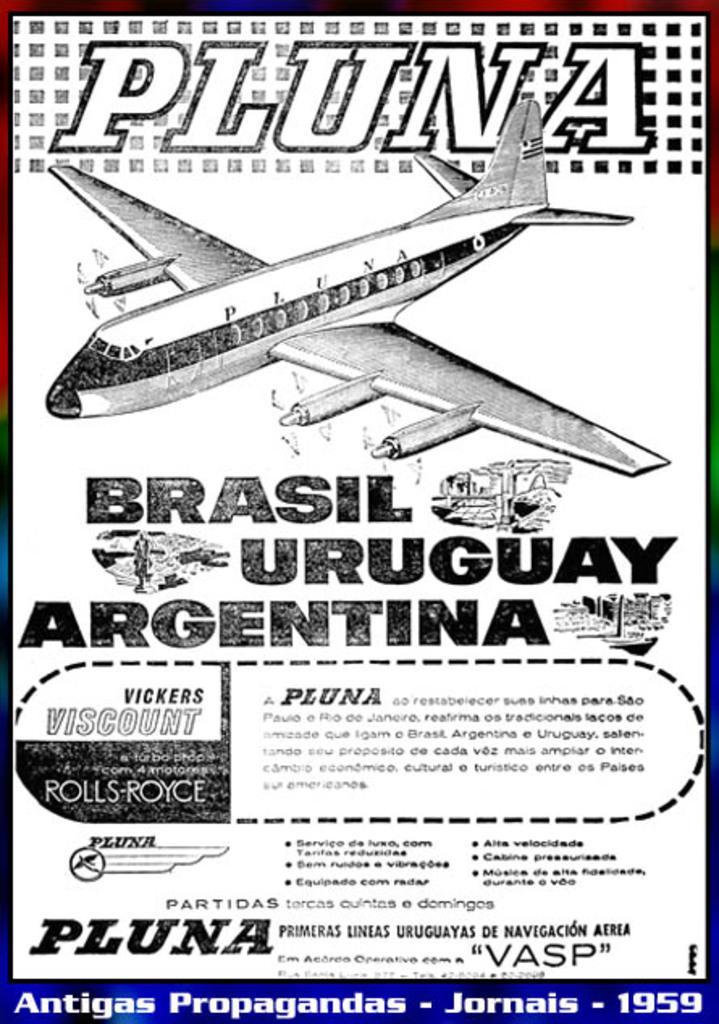In one or two sentences, can you explain what this image depicts? This is a poster. In the poster we can see there is an airplane and some text. 